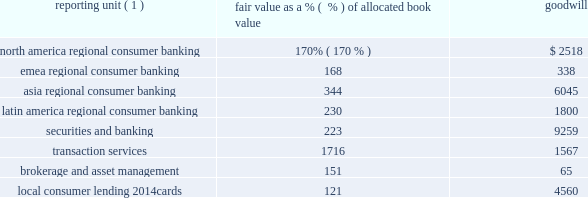The table shows reporting units with goodwill balances as of december 31 , 2010 , and the excess of fair value as a percentage over allocated book value as of the annual impairment test .
In millions of dollars reporting unit ( 1 ) fair value as a % (  % ) of allocated book value goodwill .
( 1 ) local consumer lending 2014other is excluded from the table as there is no goodwill allocated to it .
While no impairment was noted in step one of citigroup 2019s local consumer lending 2014cards reporting unit impairment test at july 1 , 2010 , goodwill present in the reporting unit may be sensitive to further deterioration as the valuation of the reporting unit is particularly dependent upon economic conditions that affect consumer credit risk and behavior .
Citigroup engaged the services of an independent valuation specialist to assist in the valuation of the reporting unit at july 1 , 2010 , using a combination of the market approach and income approach consistent with the valuation model used in past practice , which considered the impact of the penalty fee provisions associated with the credit card accountability responsibility and disclosure act of 2009 ( card act ) that were implemented during 2010 .
Under the market approach for valuing this reporting unit , the key assumption is the selected price multiple .
The selection of the multiple considers the operating performance and financial condition of the local consumer lending 2014cards operations as compared with those of a group of selected publicly traded guideline companies and a group of selected acquired companies .
Among other factors , the level and expected growth in return on tangible equity relative to those of the guideline companies and guideline transactions is considered .
Since the guideline company prices used are on a minority interest basis , the selection of the multiple considers the guideline acquisition prices , which reflect control rights and privileges , in arriving at a multiple that reflects an appropriate control premium .
For the local consumer lending 2014cards valuation under the income approach , the assumptions used as the basis for the model include cash flows for the forecasted period , the assumptions embedded in arriving at an estimation of the terminal value and the discount rate .
The cash flows for the forecasted period are estimated based on management 2019s most recent projections available as of the testing date , giving consideration to targeted equity capital requirements based on selected public guideline companies for the reporting unit .
In arriving at the terminal value for local consumer lending 2014cards , using 2013 as the terminal year , the assumptions used include a long-term growth rate and a price-to-tangible book multiple based on selected public guideline companies for the reporting unit .
The discount rate is based on the reporting unit 2019s estimated cost of equity capital computed under the capital asset pricing model .
Embedded in the key assumptions underlying the valuation model , described above , is the inherent uncertainty regarding the possibility that economic conditions may deteriorate or other events will occur that will impact the business model for local consumer lending 2014cards .
While there is inherent uncertainty embedded in the assumptions used in developing management 2019s forecasts , the company utilized a discount rate at july 1 , 2010 that it believes reflects the risk characteristics and uncertainty specific to management 2019s forecasts and assumptions for the local consumer lending 2014cards reporting unit .
Two primary categories of events exist 2014economic conditions in the u.s .
And regulatory actions 2014which , if they were to occur , could negatively affect key assumptions used in the valuation of local consumer lending 2014cards .
Small deterioration in the assumptions used in the valuations , in particular the discount-rate and growth-rate assumptions used in the net income projections , could significantly affect citigroup 2019s impairment evaluation and , hence , results .
If the future were to differ adversely from management 2019s best estimate of key economic assumptions , and associated cash flows were to decrease by a small margin , citi could potentially experience future material impairment charges with respect to $ 4560 million of goodwill remaining in the local consumer lending 2014 cards reporting unit .
Any such charges , by themselves , would not negatively affect citi 2019s tier 1 and total capital regulatory ratios , tier 1 common ratio , its tangible common equity or citi 2019s liquidity position. .
What was the fair value amount of emea regional consumer banking? 
Computations: (168 * 338)
Answer: 56784.0. 